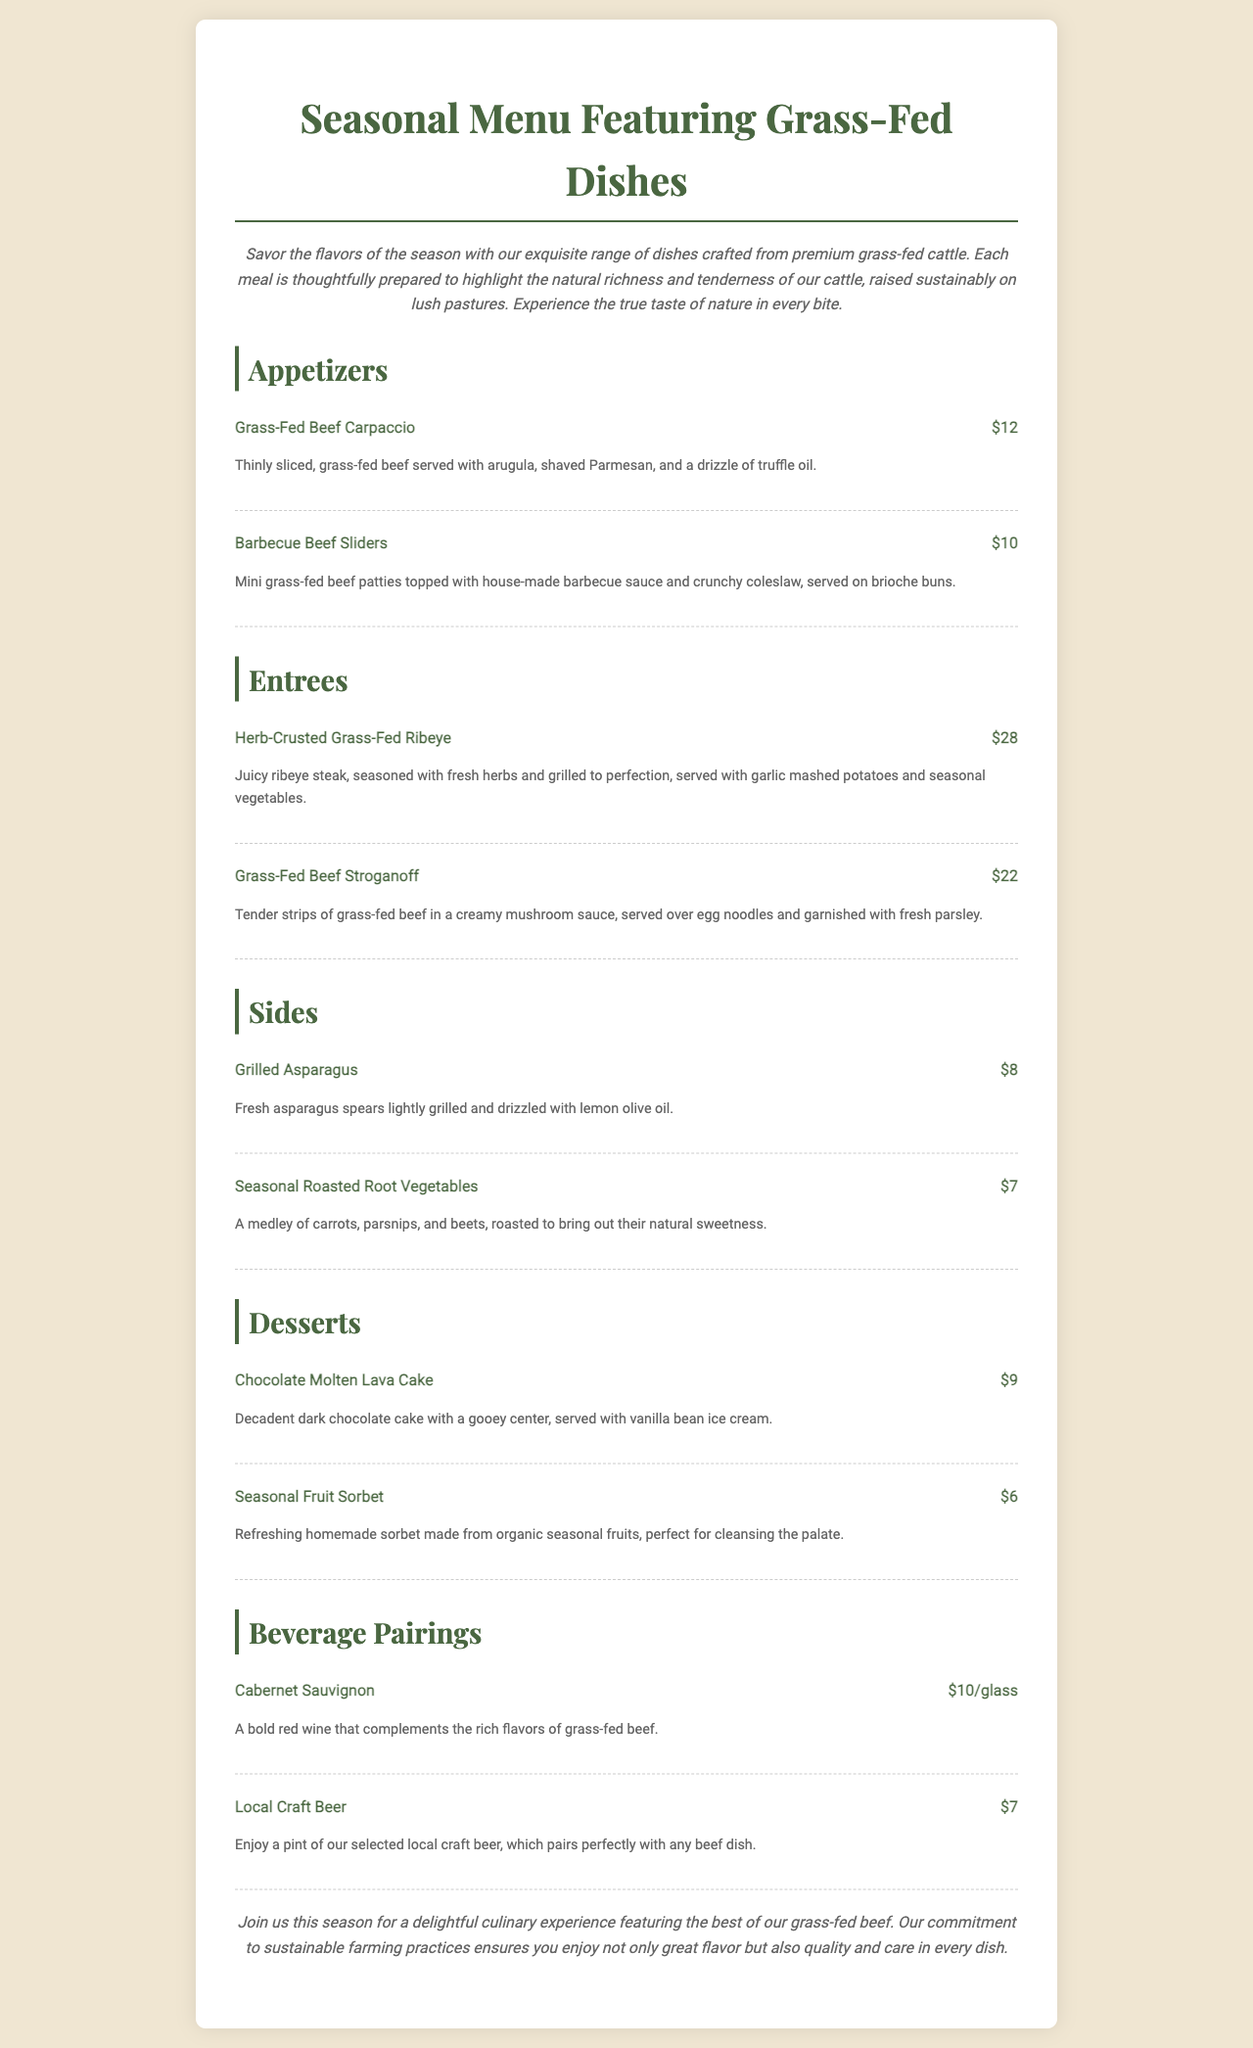What is the name of the first appetizer? The document lists the first appetizer as "Grass-Fed Beef Carpaccio".
Answer: Grass-Fed Beef Carpaccio How much does the Herb-Crusted Grass-Fed Ribeye cost? The menu states the price of the Herb-Crusted Grass-Fed Ribeye is $28.
Answer: $28 What is included in the Barbecue Beef Sliders? The description mentions mini grass-fed beef patties, house-made barbecue sauce, and crunchy coleslaw served on brioche buns.
Answer: Mini grass-fed beef patties, house-made barbecue sauce, and crunchy coleslaw What type of wine is suggested for beverage pairing? The menu recommends "Cabernet Sauvignon" as a good pairing for grass-fed beef dishes.
Answer: Cabernet Sauvignon What is the dessert option priced at $6? The menu lists "Seasonal Fruit Sorbet" as the dessert priced at $6.
Answer: Seasonal Fruit Sorbet How many sides are offered on the menu? The document lists two sides: Grilled Asparagus and Seasonal Roasted Root Vegetables.
Answer: Two What flavors does the Chocolate Molten Lava Cake feature? The description states that the cake is made of decadent dark chocolate with a gooey center.
Answer: Decadent dark chocolate with a gooey center What is the main theme of the menu? The introduction highlights a focus on grass-fed dishes crafted from premium cattle raised sustainably.
Answer: Grass-fed dishes What are the main ingredients in the Grass-Fed Beef Stroganoff? The description notes that it contains tender strips of grass-fed beef, creamy mushroom sauce, and egg noodles.
Answer: Tender strips of grass-fed beef, creamy mushroom sauce, and egg noodles 